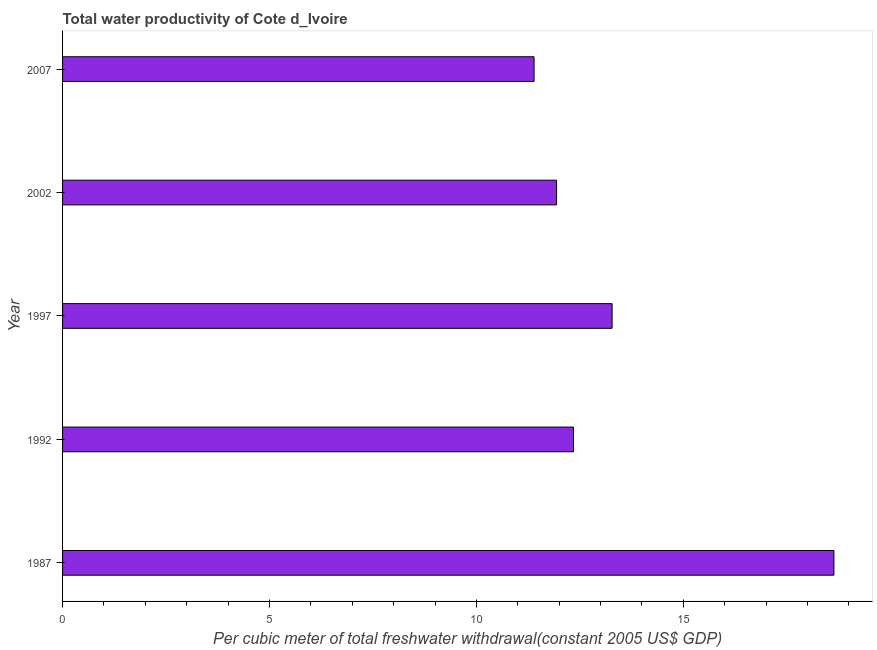Does the graph contain any zero values?
Your answer should be very brief. No. What is the title of the graph?
Ensure brevity in your answer.  Total water productivity of Cote d_Ivoire. What is the label or title of the X-axis?
Keep it short and to the point. Per cubic meter of total freshwater withdrawal(constant 2005 US$ GDP). What is the total water productivity in 2007?
Make the answer very short. 11.39. Across all years, what is the maximum total water productivity?
Offer a terse response. 18.64. Across all years, what is the minimum total water productivity?
Offer a terse response. 11.39. What is the sum of the total water productivity?
Provide a short and direct response. 67.6. What is the difference between the total water productivity in 1992 and 2002?
Ensure brevity in your answer.  0.41. What is the average total water productivity per year?
Offer a very short reply. 13.52. What is the median total water productivity?
Give a very brief answer. 12.35. Do a majority of the years between 2002 and 2007 (inclusive) have total water productivity greater than 15 US$?
Provide a short and direct response. No. What is the ratio of the total water productivity in 1987 to that in 2007?
Provide a short and direct response. 1.64. Is the difference between the total water productivity in 1987 and 2002 greater than the difference between any two years?
Make the answer very short. No. What is the difference between the highest and the second highest total water productivity?
Your response must be concise. 5.36. What is the difference between the highest and the lowest total water productivity?
Your response must be concise. 7.25. Are all the bars in the graph horizontal?
Make the answer very short. Yes. What is the difference between two consecutive major ticks on the X-axis?
Ensure brevity in your answer.  5. Are the values on the major ticks of X-axis written in scientific E-notation?
Provide a succinct answer. No. What is the Per cubic meter of total freshwater withdrawal(constant 2005 US$ GDP) in 1987?
Offer a terse response. 18.64. What is the Per cubic meter of total freshwater withdrawal(constant 2005 US$ GDP) of 1992?
Make the answer very short. 12.35. What is the Per cubic meter of total freshwater withdrawal(constant 2005 US$ GDP) in 1997?
Ensure brevity in your answer.  13.28. What is the Per cubic meter of total freshwater withdrawal(constant 2005 US$ GDP) in 2002?
Provide a succinct answer. 11.94. What is the Per cubic meter of total freshwater withdrawal(constant 2005 US$ GDP) in 2007?
Provide a short and direct response. 11.39. What is the difference between the Per cubic meter of total freshwater withdrawal(constant 2005 US$ GDP) in 1987 and 1992?
Your answer should be compact. 6.29. What is the difference between the Per cubic meter of total freshwater withdrawal(constant 2005 US$ GDP) in 1987 and 1997?
Your response must be concise. 5.36. What is the difference between the Per cubic meter of total freshwater withdrawal(constant 2005 US$ GDP) in 1987 and 2002?
Provide a short and direct response. 6.7. What is the difference between the Per cubic meter of total freshwater withdrawal(constant 2005 US$ GDP) in 1987 and 2007?
Keep it short and to the point. 7.25. What is the difference between the Per cubic meter of total freshwater withdrawal(constant 2005 US$ GDP) in 1992 and 1997?
Give a very brief answer. -0.93. What is the difference between the Per cubic meter of total freshwater withdrawal(constant 2005 US$ GDP) in 1992 and 2002?
Your answer should be very brief. 0.41. What is the difference between the Per cubic meter of total freshwater withdrawal(constant 2005 US$ GDP) in 1992 and 2007?
Your answer should be very brief. 0.95. What is the difference between the Per cubic meter of total freshwater withdrawal(constant 2005 US$ GDP) in 1997 and 2002?
Your answer should be compact. 1.34. What is the difference between the Per cubic meter of total freshwater withdrawal(constant 2005 US$ GDP) in 1997 and 2007?
Ensure brevity in your answer.  1.89. What is the difference between the Per cubic meter of total freshwater withdrawal(constant 2005 US$ GDP) in 2002 and 2007?
Your response must be concise. 0.54. What is the ratio of the Per cubic meter of total freshwater withdrawal(constant 2005 US$ GDP) in 1987 to that in 1992?
Your answer should be compact. 1.51. What is the ratio of the Per cubic meter of total freshwater withdrawal(constant 2005 US$ GDP) in 1987 to that in 1997?
Offer a terse response. 1.4. What is the ratio of the Per cubic meter of total freshwater withdrawal(constant 2005 US$ GDP) in 1987 to that in 2002?
Provide a succinct answer. 1.56. What is the ratio of the Per cubic meter of total freshwater withdrawal(constant 2005 US$ GDP) in 1987 to that in 2007?
Give a very brief answer. 1.64. What is the ratio of the Per cubic meter of total freshwater withdrawal(constant 2005 US$ GDP) in 1992 to that in 2002?
Provide a short and direct response. 1.03. What is the ratio of the Per cubic meter of total freshwater withdrawal(constant 2005 US$ GDP) in 1992 to that in 2007?
Make the answer very short. 1.08. What is the ratio of the Per cubic meter of total freshwater withdrawal(constant 2005 US$ GDP) in 1997 to that in 2002?
Ensure brevity in your answer.  1.11. What is the ratio of the Per cubic meter of total freshwater withdrawal(constant 2005 US$ GDP) in 1997 to that in 2007?
Your answer should be very brief. 1.17. What is the ratio of the Per cubic meter of total freshwater withdrawal(constant 2005 US$ GDP) in 2002 to that in 2007?
Give a very brief answer. 1.05. 